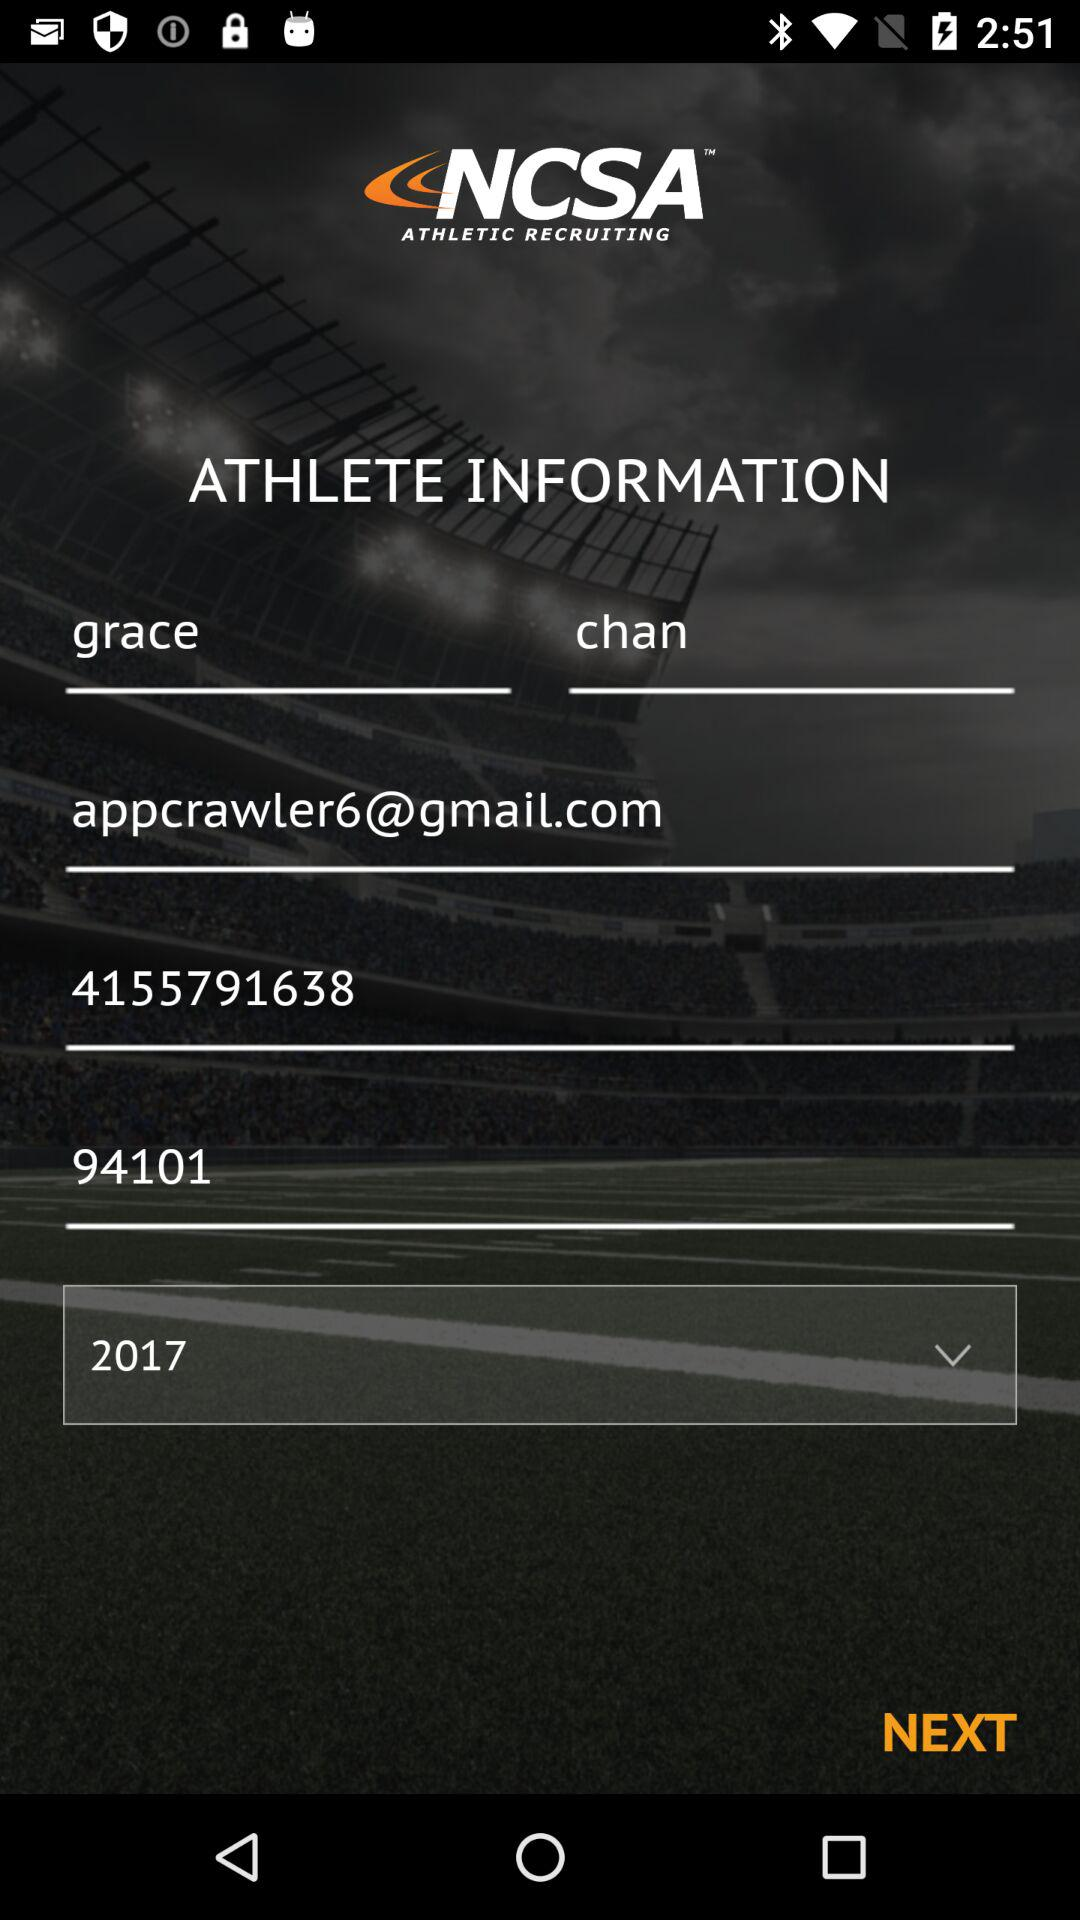What is the email ID of Grace? The email ID of Grace is appcrawler6@gmail.com. 